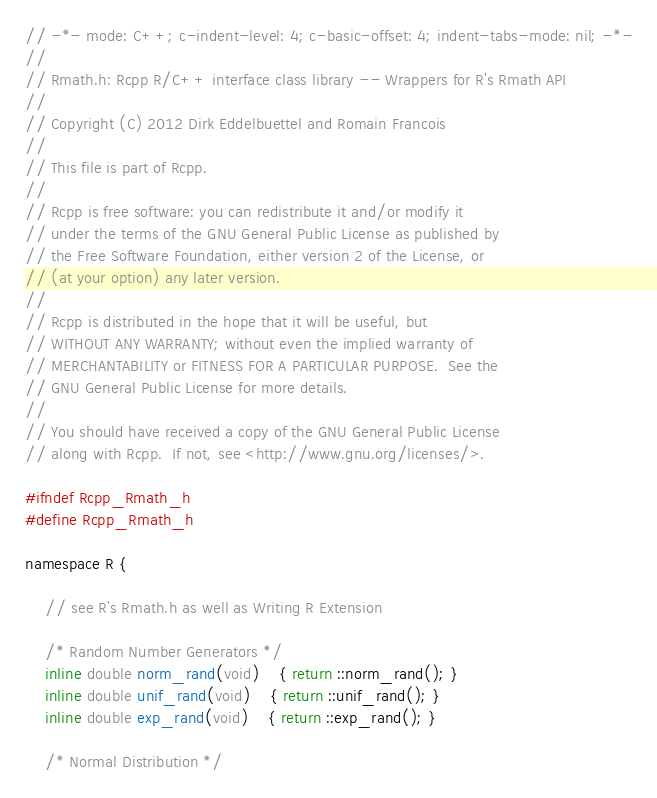Convert code to text. <code><loc_0><loc_0><loc_500><loc_500><_C_>// -*- mode: C++; c-indent-level: 4; c-basic-offset: 4; indent-tabs-mode: nil; -*-
//
// Rmath.h: Rcpp R/C++ interface class library -- Wrappers for R's Rmath API
//
// Copyright (C) 2012 Dirk Eddelbuettel and Romain Francois
//
// This file is part of Rcpp.
//
// Rcpp is free software: you can redistribute it and/or modify it
// under the terms of the GNU General Public License as published by
// the Free Software Foundation, either version 2 of the License, or
// (at your option) any later version.
//
// Rcpp is distributed in the hope that it will be useful, but
// WITHOUT ANY WARRANTY; without even the implied warranty of
// MERCHANTABILITY or FITNESS FOR A PARTICULAR PURPOSE.  See the
// GNU General Public License for more details.
//
// You should have received a copy of the GNU General Public License
// along with Rcpp.  If not, see <http://www.gnu.org/licenses/>.

#ifndef Rcpp_Rmath_h
#define Rcpp_Rmath_h

namespace R {

    // see R's Rmath.h as well as Writing R Extension

    /* Random Number Generators */
    inline double norm_rand(void) 	{ return ::norm_rand(); }
    inline double unif_rand(void)	{ return ::unif_rand(); }
    inline double exp_rand(void)	{ return ::exp_rand(); }

    /* Normal Distribution */</code> 